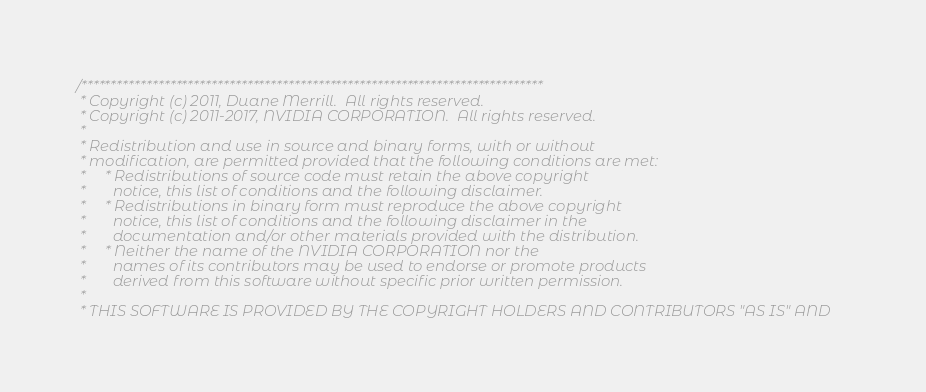<code> <loc_0><loc_0><loc_500><loc_500><_Cuda_>/******************************************************************************
 * Copyright (c) 2011, Duane Merrill.  All rights reserved.
 * Copyright (c) 2011-2017, NVIDIA CORPORATION.  All rights reserved.
 *
 * Redistribution and use in source and binary forms, with or without
 * modification, are permitted provided that the following conditions are met:
 *     * Redistributions of source code must retain the above copyright
 *       notice, this list of conditions and the following disclaimer.
 *     * Redistributions in binary form must reproduce the above copyright
 *       notice, this list of conditions and the following disclaimer in the
 *       documentation and/or other materials provided with the distribution.
 *     * Neither the name of the NVIDIA CORPORATION nor the
 *       names of its contributors may be used to endorse or promote products
 *       derived from this software without specific prior written permission.
 *
 * THIS SOFTWARE IS PROVIDED BY THE COPYRIGHT HOLDERS AND CONTRIBUTORS "AS IS" AND</code> 